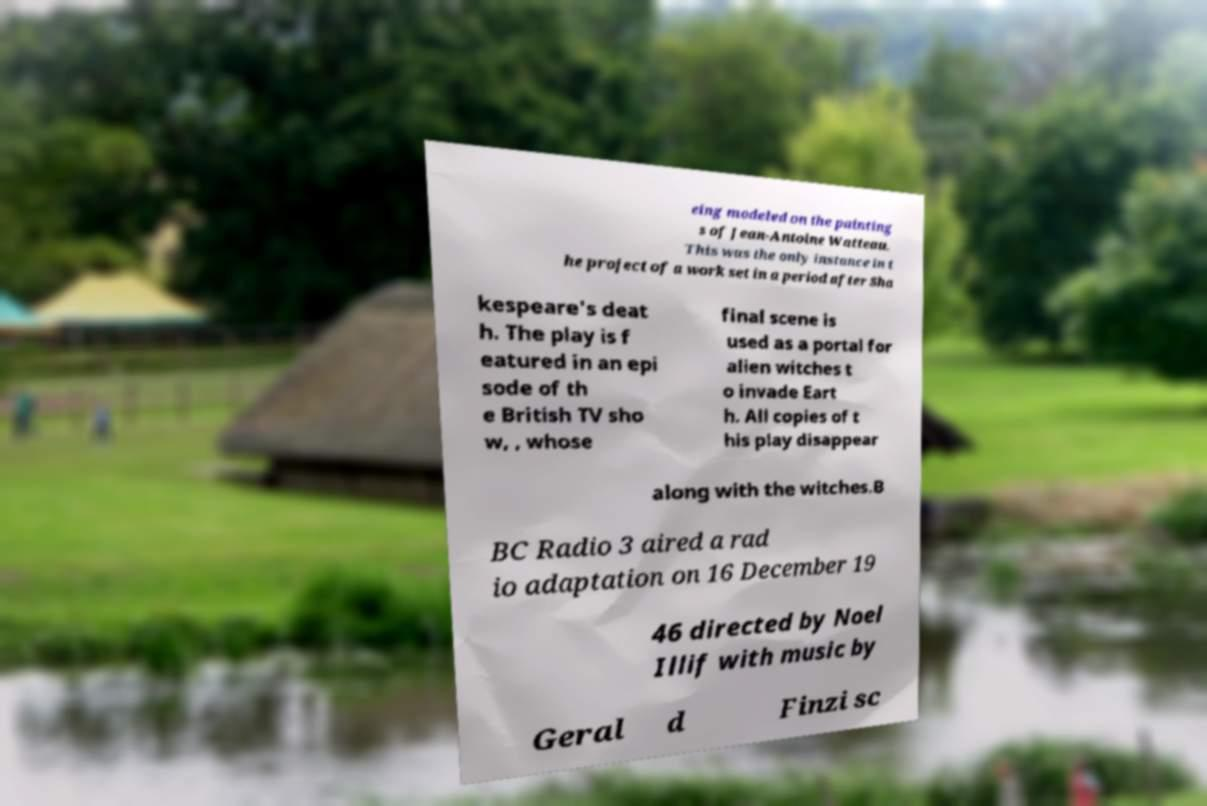What messages or text are displayed in this image? I need them in a readable, typed format. eing modeled on the painting s of Jean-Antoine Watteau. This was the only instance in t he project of a work set in a period after Sha kespeare's deat h. The play is f eatured in an epi sode of th e British TV sho w, , whose final scene is used as a portal for alien witches t o invade Eart h. All copies of t his play disappear along with the witches.B BC Radio 3 aired a rad io adaptation on 16 December 19 46 directed by Noel Illif with music by Geral d Finzi sc 